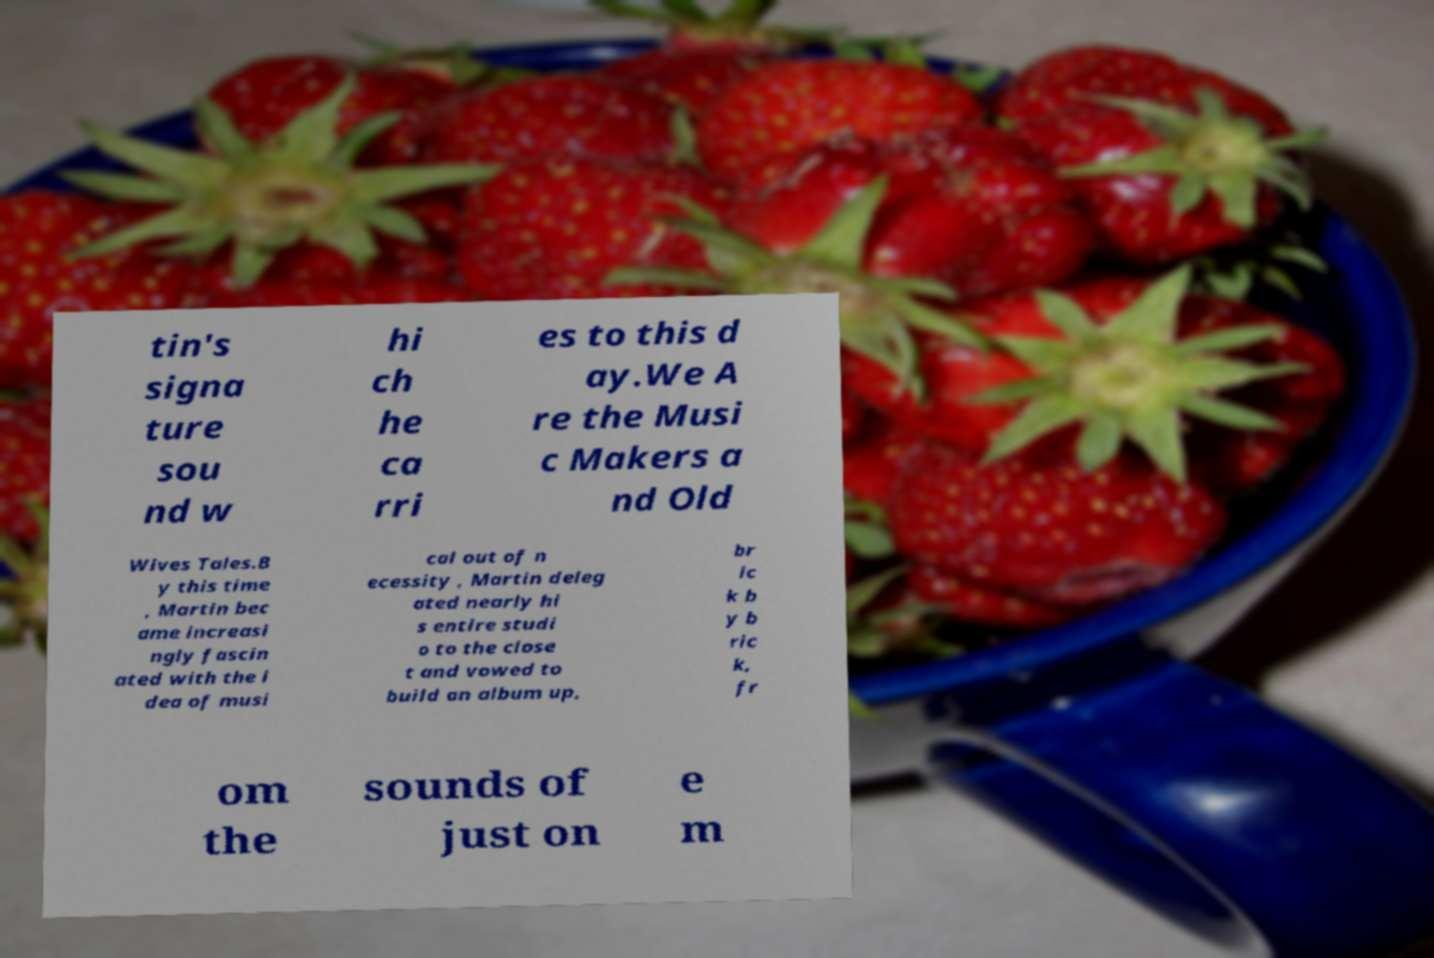I need the written content from this picture converted into text. Can you do that? tin's signa ture sou nd w hi ch he ca rri es to this d ay.We A re the Musi c Makers a nd Old Wives Tales.B y this time , Martin bec ame increasi ngly fascin ated with the i dea of musi cal out of n ecessity , Martin deleg ated nearly hi s entire studi o to the close t and vowed to build an album up, br ic k b y b ric k, fr om the sounds of just on e m 